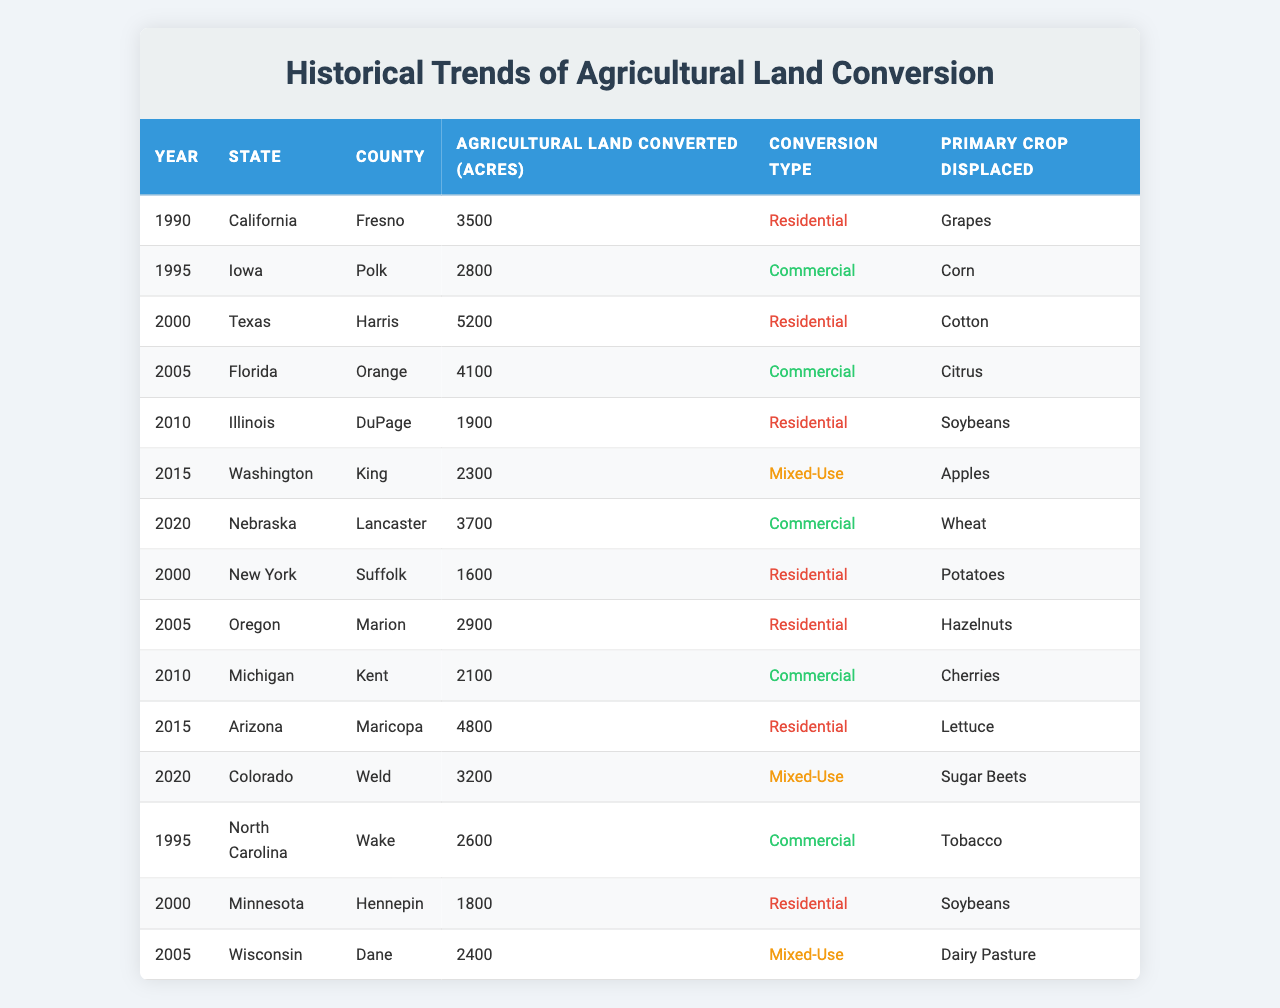What year had the highest agricultural land conversion for residential use? Looking at the "Conversion Type" column, I will identify which entries each fall under "Residential." The highest value of agricultural land converted to residential use is in 2000, with 5200 acres in Texas.
Answer: 2000 How many acres of agricultural land were converted in Iowa? Referring to the table, Iowa has one entry, in 1995, where 2800 acres were converted.
Answer: 2800 Which crop was primarily displaced in Nebraska in 2020? I will look at the row for Nebraska in the year 2020 and see that “Wheat” was the crop displaced.
Answer: Wheat How many total acres were converted for mixed-use from the data provided? I will identify the rows with "Mixed-Use" as the conversion type. There are two entries: 2300 acres in 2015 (Washington) and 3200 acres in 2020 (Colorado). Adding these two gives: 2300 + 3200 = 5500 acres.
Answer: 5500 Did any counties convert agricultural land to residential use in both the years 2000 and 2015? I will check the entries for 2000 and 2015. In 2000, there was residential conversion in Suffolk County, New York but in 2015, it was Amber County, Arizona. Therefore, there were no counties converting land in both years for residential use.
Answer: No Which state had the most acreage converted to residential use from 1990 to 2015, based on the data? I will consider the residential conversions in the years shown: 3500 acres in California (1990), 5200 acres in Texas (2000), 1900 acres in Illinois (2010), and 4800 acres in Arizona (2015). Adding them up gives: 3500 + 5200 + 1900 + 4800 = 15400 acres, with Texas having the highest single-entry value of 5200 acres in 2000.
Answer: Texas What was the primary crop displaced by the most acres converted for commercial use? From the table, the commercial conversions are 2800 acres in Iowa (Corn), 4100 acres in Florida (Citrus), 2600 acres in North Carolina (Tobacco), 2100 acres in Michigan (Cherries), and 3700 acres in Nebraska (Wheat). The most acres converted was 4100 in Florida, displacing Citrus.
Answer: Citrus Which year saw the least conversion of agricultural land across all states? I will examine the table for the smallest number in the "Agricultural Land Converted" column. The entry for Illinois in 2010 has the lowest value at 1900 acres.
Answer: 2010 